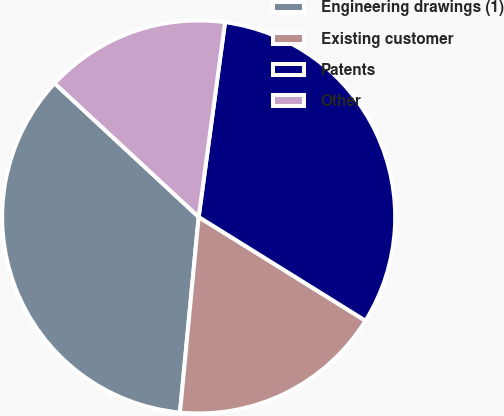<chart> <loc_0><loc_0><loc_500><loc_500><pie_chart><fcel>Engineering drawings (1)<fcel>Existing customer<fcel>Patents<fcel>Other<nl><fcel>35.39%<fcel>17.66%<fcel>31.72%<fcel>15.24%<nl></chart> 